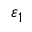Convert formula to latex. <formula><loc_0><loc_0><loc_500><loc_500>\varepsilon _ { 1 }</formula> 